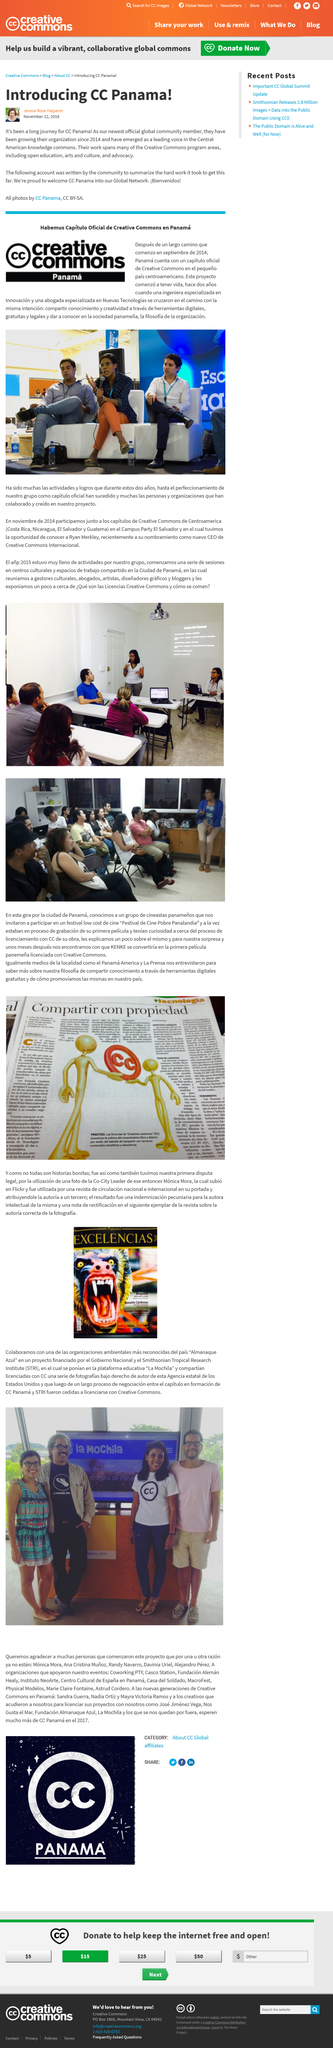Point out several critical features in this image. Since 2014, CC Panama has been expanding its organization. On November 22, 2016, Jennie Rose Halperine introduced CC Panama. The Central America knowledge commons produced a prominent figure who was CC Panama. The intent of the individuals who initiated the project was to promote the sharing of knowledge and creativity through free, legal digital resources, while raising awareness of the organization's values among the people of Panama. The project began to come to life about two years ago. 